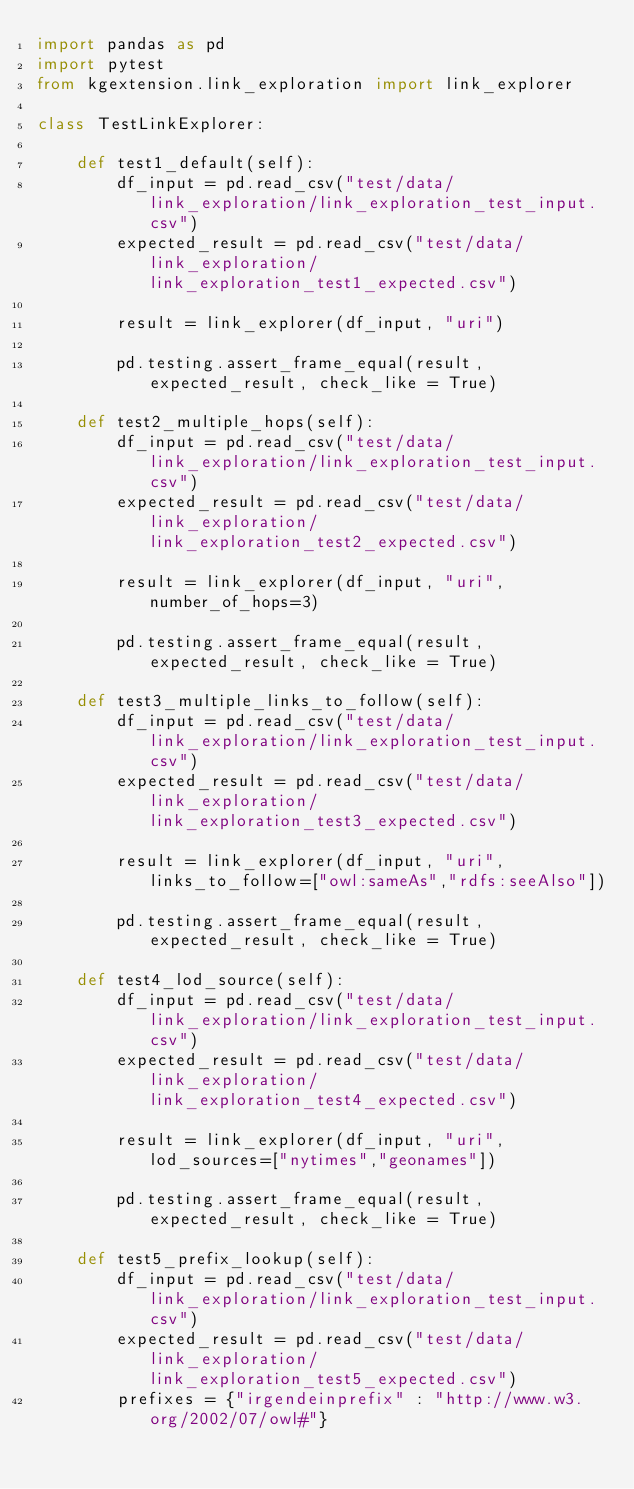<code> <loc_0><loc_0><loc_500><loc_500><_Python_>import pandas as pd
import pytest
from kgextension.link_exploration import link_explorer

class TestLinkExplorer:

    def test1_default(self):
        df_input = pd.read_csv("test/data/link_exploration/link_exploration_test_input.csv")
        expected_result = pd.read_csv("test/data/link_exploration/link_exploration_test1_expected.csv")

        result = link_explorer(df_input, "uri")

        pd.testing.assert_frame_equal(result, expected_result, check_like = True)
    
    def test2_multiple_hops(self):
        df_input = pd.read_csv("test/data/link_exploration/link_exploration_test_input.csv")
        expected_result = pd.read_csv("test/data/link_exploration/link_exploration_test2_expected.csv")

        result = link_explorer(df_input, "uri", number_of_hops=3)

        pd.testing.assert_frame_equal(result, expected_result, check_like = True)
    
    def test3_multiple_links_to_follow(self):
        df_input = pd.read_csv("test/data/link_exploration/link_exploration_test_input.csv")
        expected_result = pd.read_csv("test/data/link_exploration/link_exploration_test3_expected.csv")

        result = link_explorer(df_input, "uri", links_to_follow=["owl:sameAs","rdfs:seeAlso"])

        pd.testing.assert_frame_equal(result, expected_result, check_like = True)
    
    def test4_lod_source(self):
        df_input = pd.read_csv("test/data/link_exploration/link_exploration_test_input.csv")
        expected_result = pd.read_csv("test/data/link_exploration/link_exploration_test4_expected.csv")

        result = link_explorer(df_input, "uri", lod_sources=["nytimes","geonames"])

        pd.testing.assert_frame_equal(result, expected_result, check_like = True)

    def test5_prefix_lookup(self):
        df_input = pd.read_csv("test/data/link_exploration/link_exploration_test_input.csv")
        expected_result = pd.read_csv("test/data/link_exploration/link_exploration_test5_expected.csv")
        prefixes = {"irgendeinprefix" : "http://www.w3.org/2002/07/owl#"}
</code> 